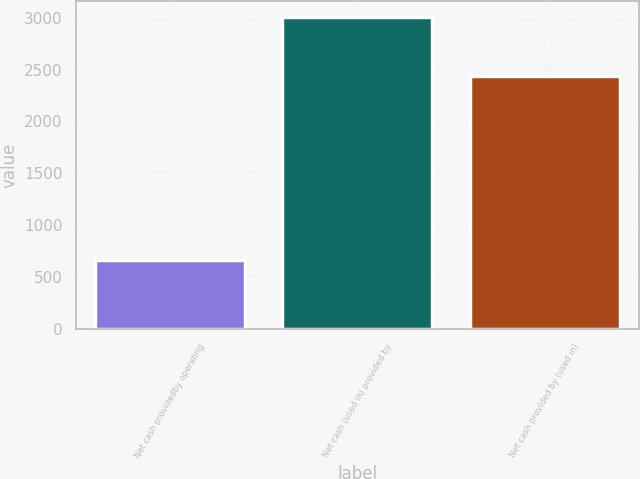Convert chart to OTSL. <chart><loc_0><loc_0><loc_500><loc_500><bar_chart><fcel>Net cash providedby operating<fcel>Net cash (used in) provided by<fcel>Net cash provided by (used in)<nl><fcel>663.8<fcel>3006.3<fcel>2440.9<nl></chart> 